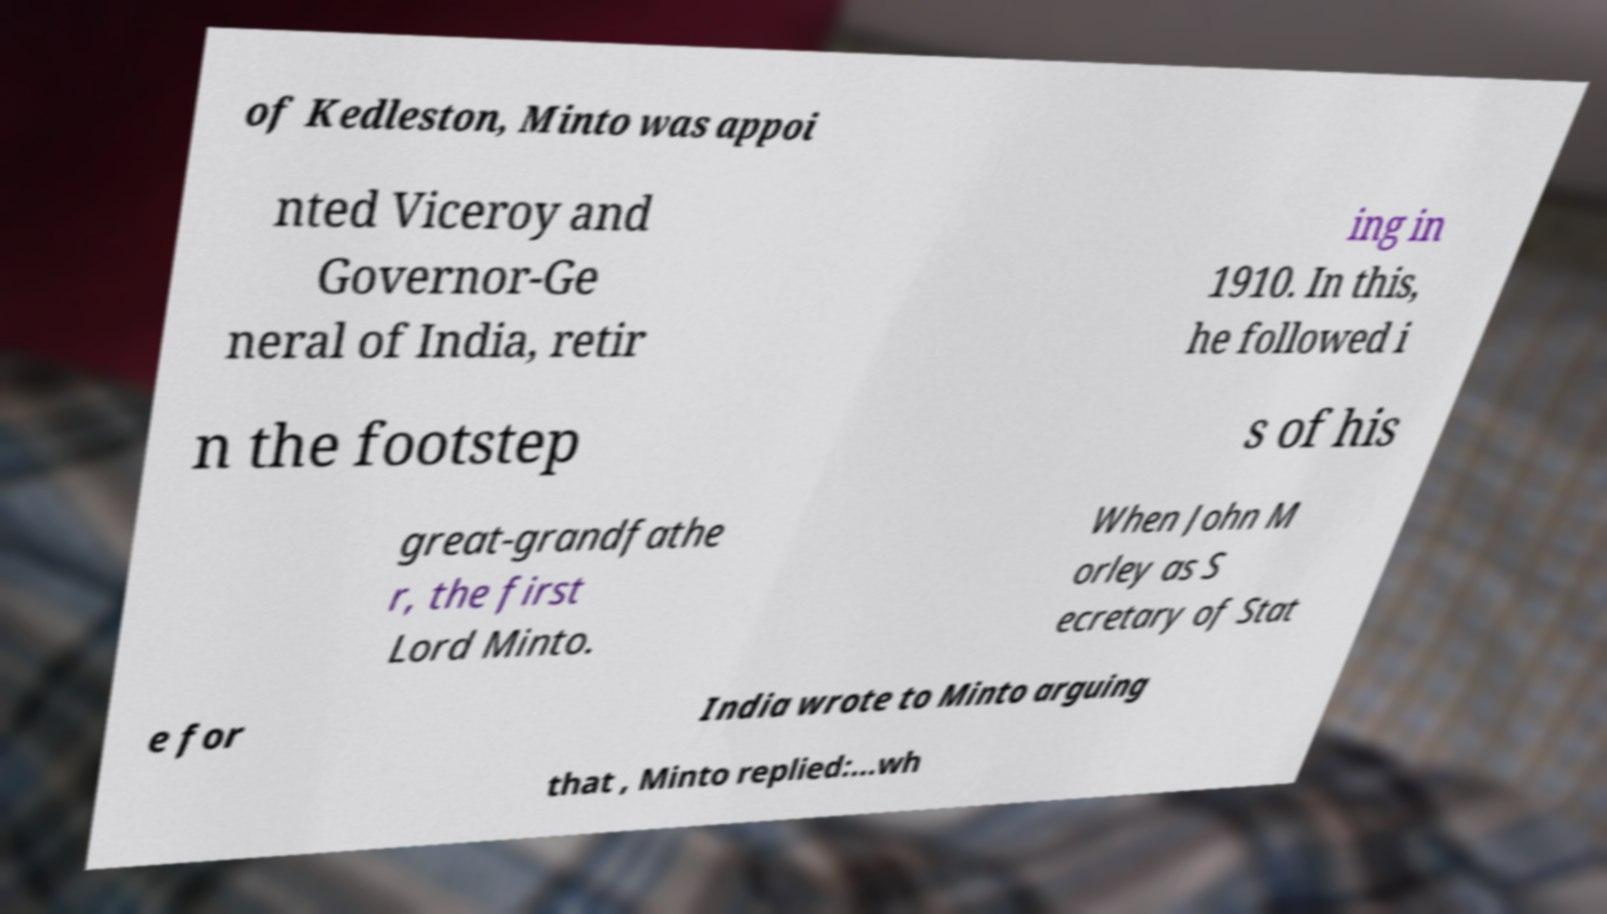Could you assist in decoding the text presented in this image and type it out clearly? of Kedleston, Minto was appoi nted Viceroy and Governor-Ge neral of India, retir ing in 1910. In this, he followed i n the footstep s of his great-grandfathe r, the first Lord Minto. When John M orley as S ecretary of Stat e for India wrote to Minto arguing that , Minto replied:...wh 